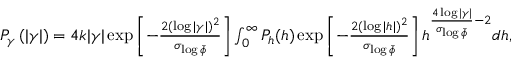Convert formula to latex. <formula><loc_0><loc_0><loc_500><loc_500>\begin{array} { r } { P _ { \gamma } \left ( | \gamma | \right ) = 4 k | \gamma | \exp \left [ - \frac { 2 ( \log | \gamma | ) ^ { 2 } } { \sigma _ { \log \bar { \phi } } } \right ] \int _ { 0 } ^ { \infty } P _ { h } ( h ) \exp \left [ - \frac { 2 ( \log | h | ) ^ { 2 } } { \sigma _ { \log \bar { \phi } } } \right ] h ^ { \frac { 4 \log | \gamma | } { \sigma _ { \log \bar { \phi } } } - 2 } d h , } \end{array}</formula> 